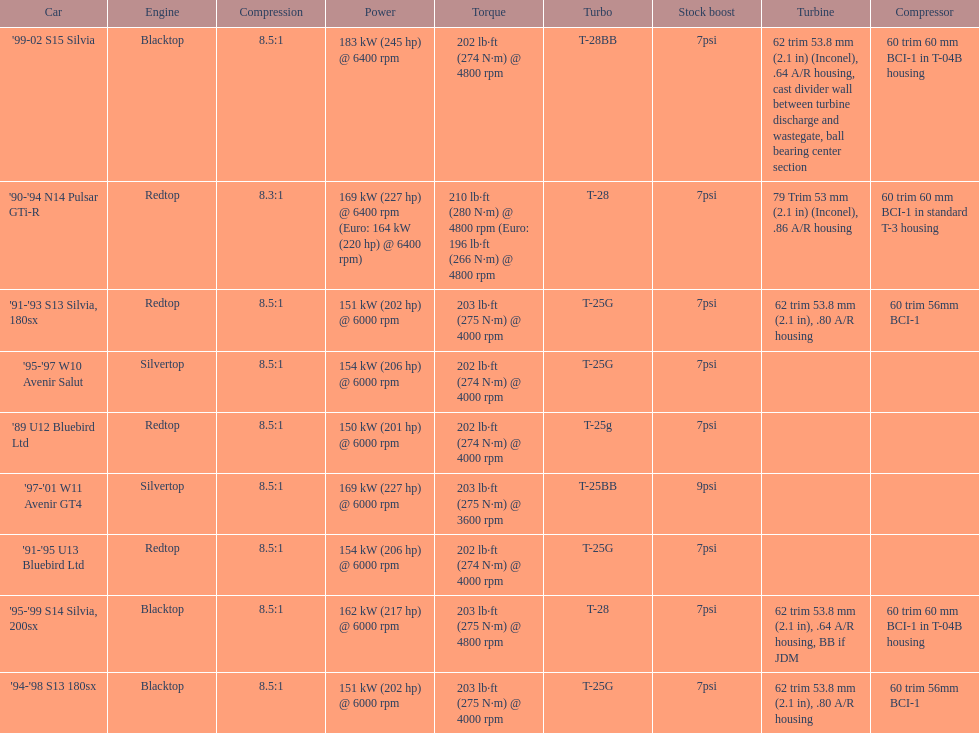Which engines are the same as the first entry ('89 u12 bluebird ltd)? '91-'95 U13 Bluebird Ltd, '90-'94 N14 Pulsar GTi-R, '91-'93 S13 Silvia, 180sx. 